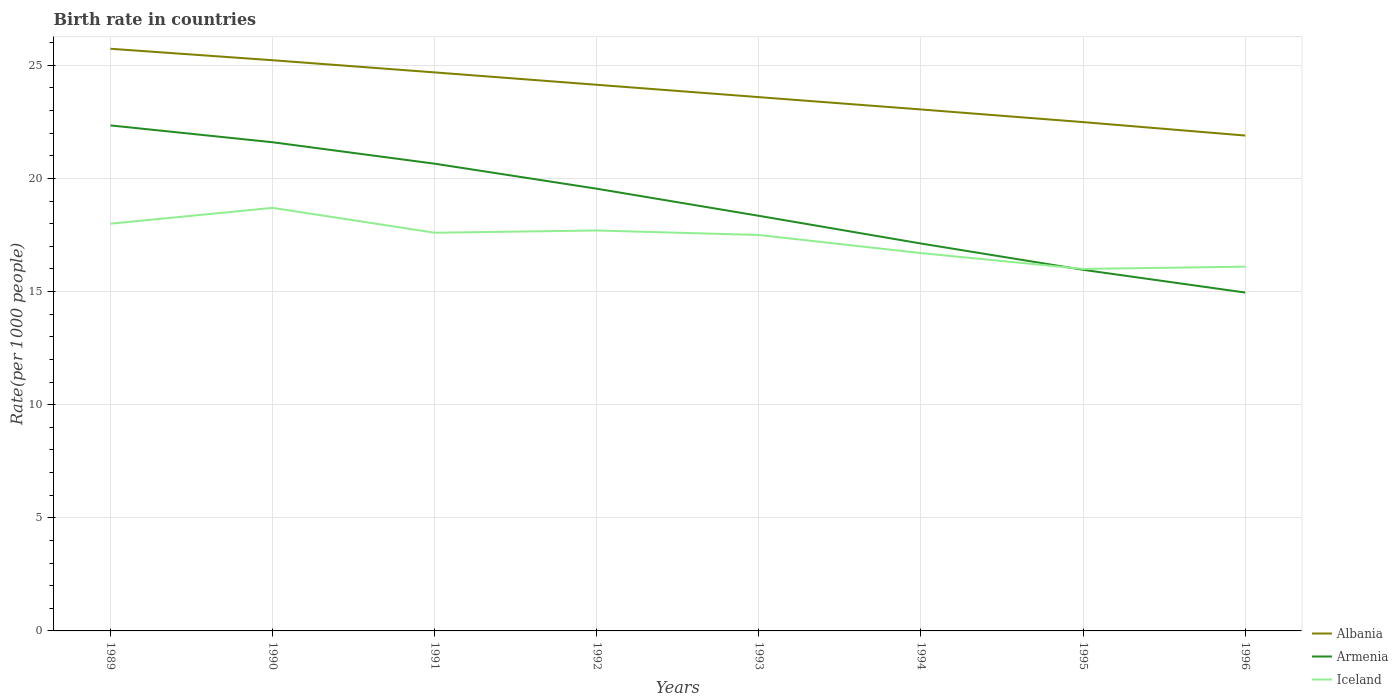How many different coloured lines are there?
Keep it short and to the point. 3. Does the line corresponding to Iceland intersect with the line corresponding to Albania?
Your answer should be very brief. No. Across all years, what is the maximum birth rate in Armenia?
Ensure brevity in your answer.  14.96. In which year was the birth rate in Albania maximum?
Your response must be concise. 1996. What is the total birth rate in Iceland in the graph?
Make the answer very short. 1.6. What is the difference between the highest and the second highest birth rate in Iceland?
Ensure brevity in your answer.  2.7. What is the difference between the highest and the lowest birth rate in Albania?
Provide a succinct answer. 4. How many lines are there?
Make the answer very short. 3. Are the values on the major ticks of Y-axis written in scientific E-notation?
Keep it short and to the point. No. Does the graph contain grids?
Your answer should be compact. Yes. Where does the legend appear in the graph?
Give a very brief answer. Bottom right. What is the title of the graph?
Offer a terse response. Birth rate in countries. Does "South Africa" appear as one of the legend labels in the graph?
Give a very brief answer. No. What is the label or title of the X-axis?
Ensure brevity in your answer.  Years. What is the label or title of the Y-axis?
Your answer should be compact. Rate(per 1000 people). What is the Rate(per 1000 people) of Albania in 1989?
Your answer should be compact. 25.73. What is the Rate(per 1000 people) of Armenia in 1989?
Keep it short and to the point. 22.34. What is the Rate(per 1000 people) in Albania in 1990?
Provide a short and direct response. 25.23. What is the Rate(per 1000 people) in Armenia in 1990?
Ensure brevity in your answer.  21.6. What is the Rate(per 1000 people) of Albania in 1991?
Offer a terse response. 24.69. What is the Rate(per 1000 people) in Armenia in 1991?
Offer a very short reply. 20.65. What is the Rate(per 1000 people) in Albania in 1992?
Your answer should be compact. 24.14. What is the Rate(per 1000 people) of Armenia in 1992?
Provide a short and direct response. 19.55. What is the Rate(per 1000 people) of Albania in 1993?
Provide a short and direct response. 23.59. What is the Rate(per 1000 people) in Armenia in 1993?
Offer a terse response. 18.35. What is the Rate(per 1000 people) in Albania in 1994?
Provide a succinct answer. 23.05. What is the Rate(per 1000 people) in Armenia in 1994?
Ensure brevity in your answer.  17.12. What is the Rate(per 1000 people) of Albania in 1995?
Offer a very short reply. 22.49. What is the Rate(per 1000 people) of Armenia in 1995?
Keep it short and to the point. 15.96. What is the Rate(per 1000 people) of Iceland in 1995?
Provide a short and direct response. 16. What is the Rate(per 1000 people) of Albania in 1996?
Your response must be concise. 21.9. What is the Rate(per 1000 people) of Armenia in 1996?
Offer a terse response. 14.96. Across all years, what is the maximum Rate(per 1000 people) of Albania?
Provide a succinct answer. 25.73. Across all years, what is the maximum Rate(per 1000 people) in Armenia?
Provide a short and direct response. 22.34. Across all years, what is the maximum Rate(per 1000 people) of Iceland?
Offer a terse response. 18.7. Across all years, what is the minimum Rate(per 1000 people) in Albania?
Your response must be concise. 21.9. Across all years, what is the minimum Rate(per 1000 people) of Armenia?
Make the answer very short. 14.96. Across all years, what is the minimum Rate(per 1000 people) of Iceland?
Your response must be concise. 16. What is the total Rate(per 1000 people) of Albania in the graph?
Keep it short and to the point. 190.81. What is the total Rate(per 1000 people) in Armenia in the graph?
Give a very brief answer. 150.53. What is the total Rate(per 1000 people) of Iceland in the graph?
Your response must be concise. 138.3. What is the difference between the Rate(per 1000 people) in Albania in 1989 and that in 1990?
Your response must be concise. 0.51. What is the difference between the Rate(per 1000 people) of Armenia in 1989 and that in 1990?
Make the answer very short. 0.74. What is the difference between the Rate(per 1000 people) of Albania in 1989 and that in 1991?
Give a very brief answer. 1.04. What is the difference between the Rate(per 1000 people) in Armenia in 1989 and that in 1991?
Your response must be concise. 1.69. What is the difference between the Rate(per 1000 people) of Iceland in 1989 and that in 1991?
Make the answer very short. 0.4. What is the difference between the Rate(per 1000 people) in Albania in 1989 and that in 1992?
Your answer should be very brief. 1.59. What is the difference between the Rate(per 1000 people) in Armenia in 1989 and that in 1992?
Provide a succinct answer. 2.8. What is the difference between the Rate(per 1000 people) in Iceland in 1989 and that in 1992?
Provide a short and direct response. 0.3. What is the difference between the Rate(per 1000 people) of Albania in 1989 and that in 1993?
Offer a very short reply. 2.14. What is the difference between the Rate(per 1000 people) in Armenia in 1989 and that in 1993?
Provide a short and direct response. 4. What is the difference between the Rate(per 1000 people) in Iceland in 1989 and that in 1993?
Provide a short and direct response. 0.5. What is the difference between the Rate(per 1000 people) in Albania in 1989 and that in 1994?
Give a very brief answer. 2.68. What is the difference between the Rate(per 1000 people) in Armenia in 1989 and that in 1994?
Your answer should be very brief. 5.22. What is the difference between the Rate(per 1000 people) in Albania in 1989 and that in 1995?
Provide a succinct answer. 3.24. What is the difference between the Rate(per 1000 people) in Armenia in 1989 and that in 1995?
Offer a very short reply. 6.38. What is the difference between the Rate(per 1000 people) of Iceland in 1989 and that in 1995?
Your response must be concise. 2. What is the difference between the Rate(per 1000 people) in Albania in 1989 and that in 1996?
Provide a succinct answer. 3.84. What is the difference between the Rate(per 1000 people) in Armenia in 1989 and that in 1996?
Offer a terse response. 7.39. What is the difference between the Rate(per 1000 people) in Albania in 1990 and that in 1991?
Your response must be concise. 0.54. What is the difference between the Rate(per 1000 people) in Armenia in 1990 and that in 1991?
Ensure brevity in your answer.  0.95. What is the difference between the Rate(per 1000 people) of Iceland in 1990 and that in 1991?
Provide a short and direct response. 1.1. What is the difference between the Rate(per 1000 people) of Albania in 1990 and that in 1992?
Give a very brief answer. 1.08. What is the difference between the Rate(per 1000 people) in Armenia in 1990 and that in 1992?
Your answer should be compact. 2.05. What is the difference between the Rate(per 1000 people) in Albania in 1990 and that in 1993?
Provide a succinct answer. 1.63. What is the difference between the Rate(per 1000 people) in Armenia in 1990 and that in 1993?
Your answer should be compact. 3.25. What is the difference between the Rate(per 1000 people) in Albania in 1990 and that in 1994?
Your answer should be very brief. 2.18. What is the difference between the Rate(per 1000 people) of Armenia in 1990 and that in 1994?
Provide a short and direct response. 4.48. What is the difference between the Rate(per 1000 people) in Albania in 1990 and that in 1995?
Your response must be concise. 2.73. What is the difference between the Rate(per 1000 people) in Armenia in 1990 and that in 1995?
Ensure brevity in your answer.  5.64. What is the difference between the Rate(per 1000 people) of Iceland in 1990 and that in 1995?
Ensure brevity in your answer.  2.7. What is the difference between the Rate(per 1000 people) of Albania in 1990 and that in 1996?
Make the answer very short. 3.33. What is the difference between the Rate(per 1000 people) of Armenia in 1990 and that in 1996?
Provide a short and direct response. 6.64. What is the difference between the Rate(per 1000 people) of Albania in 1991 and that in 1992?
Make the answer very short. 0.55. What is the difference between the Rate(per 1000 people) of Armenia in 1991 and that in 1992?
Your response must be concise. 1.11. What is the difference between the Rate(per 1000 people) in Albania in 1991 and that in 1993?
Your answer should be compact. 1.09. What is the difference between the Rate(per 1000 people) of Armenia in 1991 and that in 1993?
Give a very brief answer. 2.3. What is the difference between the Rate(per 1000 people) of Iceland in 1991 and that in 1993?
Offer a terse response. 0.1. What is the difference between the Rate(per 1000 people) of Albania in 1991 and that in 1994?
Ensure brevity in your answer.  1.64. What is the difference between the Rate(per 1000 people) in Armenia in 1991 and that in 1994?
Ensure brevity in your answer.  3.53. What is the difference between the Rate(per 1000 people) of Albania in 1991 and that in 1995?
Make the answer very short. 2.2. What is the difference between the Rate(per 1000 people) of Armenia in 1991 and that in 1995?
Keep it short and to the point. 4.69. What is the difference between the Rate(per 1000 people) in Albania in 1991 and that in 1996?
Your response must be concise. 2.79. What is the difference between the Rate(per 1000 people) of Armenia in 1991 and that in 1996?
Make the answer very short. 5.7. What is the difference between the Rate(per 1000 people) in Albania in 1992 and that in 1993?
Give a very brief answer. 0.55. What is the difference between the Rate(per 1000 people) in Armenia in 1992 and that in 1993?
Ensure brevity in your answer.  1.2. What is the difference between the Rate(per 1000 people) of Iceland in 1992 and that in 1993?
Keep it short and to the point. 0.2. What is the difference between the Rate(per 1000 people) of Albania in 1992 and that in 1994?
Offer a very short reply. 1.09. What is the difference between the Rate(per 1000 people) in Armenia in 1992 and that in 1994?
Make the answer very short. 2.42. What is the difference between the Rate(per 1000 people) of Iceland in 1992 and that in 1994?
Your answer should be very brief. 1. What is the difference between the Rate(per 1000 people) in Albania in 1992 and that in 1995?
Ensure brevity in your answer.  1.65. What is the difference between the Rate(per 1000 people) of Armenia in 1992 and that in 1995?
Keep it short and to the point. 3.58. What is the difference between the Rate(per 1000 people) in Albania in 1992 and that in 1996?
Your response must be concise. 2.24. What is the difference between the Rate(per 1000 people) of Armenia in 1992 and that in 1996?
Your answer should be very brief. 4.59. What is the difference between the Rate(per 1000 people) in Iceland in 1992 and that in 1996?
Your response must be concise. 1.6. What is the difference between the Rate(per 1000 people) of Albania in 1993 and that in 1994?
Offer a very short reply. 0.55. What is the difference between the Rate(per 1000 people) in Armenia in 1993 and that in 1994?
Provide a short and direct response. 1.23. What is the difference between the Rate(per 1000 people) of Albania in 1993 and that in 1995?
Make the answer very short. 1.1. What is the difference between the Rate(per 1000 people) of Armenia in 1993 and that in 1995?
Provide a succinct answer. 2.39. What is the difference between the Rate(per 1000 people) of Albania in 1993 and that in 1996?
Provide a succinct answer. 1.7. What is the difference between the Rate(per 1000 people) of Armenia in 1993 and that in 1996?
Ensure brevity in your answer.  3.39. What is the difference between the Rate(per 1000 people) of Albania in 1994 and that in 1995?
Give a very brief answer. 0.56. What is the difference between the Rate(per 1000 people) of Armenia in 1994 and that in 1995?
Ensure brevity in your answer.  1.16. What is the difference between the Rate(per 1000 people) in Albania in 1994 and that in 1996?
Provide a succinct answer. 1.15. What is the difference between the Rate(per 1000 people) in Armenia in 1994 and that in 1996?
Offer a very short reply. 2.17. What is the difference between the Rate(per 1000 people) of Iceland in 1994 and that in 1996?
Make the answer very short. 0.6. What is the difference between the Rate(per 1000 people) of Albania in 1995 and that in 1996?
Keep it short and to the point. 0.59. What is the difference between the Rate(per 1000 people) of Armenia in 1995 and that in 1996?
Make the answer very short. 1. What is the difference between the Rate(per 1000 people) of Albania in 1989 and the Rate(per 1000 people) of Armenia in 1990?
Ensure brevity in your answer.  4.13. What is the difference between the Rate(per 1000 people) in Albania in 1989 and the Rate(per 1000 people) in Iceland in 1990?
Offer a very short reply. 7.03. What is the difference between the Rate(per 1000 people) of Armenia in 1989 and the Rate(per 1000 people) of Iceland in 1990?
Offer a very short reply. 3.64. What is the difference between the Rate(per 1000 people) in Albania in 1989 and the Rate(per 1000 people) in Armenia in 1991?
Provide a short and direct response. 5.08. What is the difference between the Rate(per 1000 people) of Albania in 1989 and the Rate(per 1000 people) of Iceland in 1991?
Your answer should be very brief. 8.13. What is the difference between the Rate(per 1000 people) of Armenia in 1989 and the Rate(per 1000 people) of Iceland in 1991?
Give a very brief answer. 4.74. What is the difference between the Rate(per 1000 people) of Albania in 1989 and the Rate(per 1000 people) of Armenia in 1992?
Your answer should be very brief. 6.19. What is the difference between the Rate(per 1000 people) of Albania in 1989 and the Rate(per 1000 people) of Iceland in 1992?
Provide a succinct answer. 8.03. What is the difference between the Rate(per 1000 people) in Armenia in 1989 and the Rate(per 1000 people) in Iceland in 1992?
Offer a very short reply. 4.64. What is the difference between the Rate(per 1000 people) of Albania in 1989 and the Rate(per 1000 people) of Armenia in 1993?
Make the answer very short. 7.38. What is the difference between the Rate(per 1000 people) of Albania in 1989 and the Rate(per 1000 people) of Iceland in 1993?
Provide a short and direct response. 8.23. What is the difference between the Rate(per 1000 people) in Armenia in 1989 and the Rate(per 1000 people) in Iceland in 1993?
Your answer should be very brief. 4.84. What is the difference between the Rate(per 1000 people) in Albania in 1989 and the Rate(per 1000 people) in Armenia in 1994?
Ensure brevity in your answer.  8.61. What is the difference between the Rate(per 1000 people) of Albania in 1989 and the Rate(per 1000 people) of Iceland in 1994?
Your answer should be very brief. 9.03. What is the difference between the Rate(per 1000 people) of Armenia in 1989 and the Rate(per 1000 people) of Iceland in 1994?
Provide a succinct answer. 5.64. What is the difference between the Rate(per 1000 people) in Albania in 1989 and the Rate(per 1000 people) in Armenia in 1995?
Offer a very short reply. 9.77. What is the difference between the Rate(per 1000 people) in Albania in 1989 and the Rate(per 1000 people) in Iceland in 1995?
Your answer should be compact. 9.73. What is the difference between the Rate(per 1000 people) of Armenia in 1989 and the Rate(per 1000 people) of Iceland in 1995?
Ensure brevity in your answer.  6.34. What is the difference between the Rate(per 1000 people) in Albania in 1989 and the Rate(per 1000 people) in Armenia in 1996?
Offer a very short reply. 10.78. What is the difference between the Rate(per 1000 people) in Albania in 1989 and the Rate(per 1000 people) in Iceland in 1996?
Provide a succinct answer. 9.63. What is the difference between the Rate(per 1000 people) of Armenia in 1989 and the Rate(per 1000 people) of Iceland in 1996?
Your answer should be compact. 6.24. What is the difference between the Rate(per 1000 people) in Albania in 1990 and the Rate(per 1000 people) in Armenia in 1991?
Give a very brief answer. 4.57. What is the difference between the Rate(per 1000 people) of Albania in 1990 and the Rate(per 1000 people) of Iceland in 1991?
Provide a succinct answer. 7.62. What is the difference between the Rate(per 1000 people) of Armenia in 1990 and the Rate(per 1000 people) of Iceland in 1991?
Your answer should be very brief. 4. What is the difference between the Rate(per 1000 people) of Albania in 1990 and the Rate(per 1000 people) of Armenia in 1992?
Your response must be concise. 5.68. What is the difference between the Rate(per 1000 people) in Albania in 1990 and the Rate(per 1000 people) in Iceland in 1992?
Make the answer very short. 7.53. What is the difference between the Rate(per 1000 people) in Albania in 1990 and the Rate(per 1000 people) in Armenia in 1993?
Your response must be concise. 6.88. What is the difference between the Rate(per 1000 people) of Albania in 1990 and the Rate(per 1000 people) of Iceland in 1993?
Your response must be concise. 7.72. What is the difference between the Rate(per 1000 people) in Armenia in 1990 and the Rate(per 1000 people) in Iceland in 1993?
Keep it short and to the point. 4.1. What is the difference between the Rate(per 1000 people) of Albania in 1990 and the Rate(per 1000 people) of Armenia in 1994?
Offer a terse response. 8.1. What is the difference between the Rate(per 1000 people) of Albania in 1990 and the Rate(per 1000 people) of Iceland in 1994?
Keep it short and to the point. 8.53. What is the difference between the Rate(per 1000 people) of Armenia in 1990 and the Rate(per 1000 people) of Iceland in 1994?
Provide a succinct answer. 4.9. What is the difference between the Rate(per 1000 people) in Albania in 1990 and the Rate(per 1000 people) in Armenia in 1995?
Ensure brevity in your answer.  9.26. What is the difference between the Rate(per 1000 people) of Albania in 1990 and the Rate(per 1000 people) of Iceland in 1995?
Your answer should be very brief. 9.22. What is the difference between the Rate(per 1000 people) of Armenia in 1990 and the Rate(per 1000 people) of Iceland in 1995?
Offer a terse response. 5.6. What is the difference between the Rate(per 1000 people) of Albania in 1990 and the Rate(per 1000 people) of Armenia in 1996?
Provide a short and direct response. 10.27. What is the difference between the Rate(per 1000 people) of Albania in 1990 and the Rate(per 1000 people) of Iceland in 1996?
Offer a very short reply. 9.12. What is the difference between the Rate(per 1000 people) in Armenia in 1990 and the Rate(per 1000 people) in Iceland in 1996?
Make the answer very short. 5.5. What is the difference between the Rate(per 1000 people) in Albania in 1991 and the Rate(per 1000 people) in Armenia in 1992?
Provide a short and direct response. 5.14. What is the difference between the Rate(per 1000 people) in Albania in 1991 and the Rate(per 1000 people) in Iceland in 1992?
Give a very brief answer. 6.99. What is the difference between the Rate(per 1000 people) in Armenia in 1991 and the Rate(per 1000 people) in Iceland in 1992?
Offer a very short reply. 2.95. What is the difference between the Rate(per 1000 people) of Albania in 1991 and the Rate(per 1000 people) of Armenia in 1993?
Provide a short and direct response. 6.34. What is the difference between the Rate(per 1000 people) in Albania in 1991 and the Rate(per 1000 people) in Iceland in 1993?
Ensure brevity in your answer.  7.19. What is the difference between the Rate(per 1000 people) in Armenia in 1991 and the Rate(per 1000 people) in Iceland in 1993?
Your answer should be very brief. 3.15. What is the difference between the Rate(per 1000 people) of Albania in 1991 and the Rate(per 1000 people) of Armenia in 1994?
Provide a succinct answer. 7.56. What is the difference between the Rate(per 1000 people) in Albania in 1991 and the Rate(per 1000 people) in Iceland in 1994?
Provide a succinct answer. 7.99. What is the difference between the Rate(per 1000 people) of Armenia in 1991 and the Rate(per 1000 people) of Iceland in 1994?
Your answer should be compact. 3.95. What is the difference between the Rate(per 1000 people) of Albania in 1991 and the Rate(per 1000 people) of Armenia in 1995?
Make the answer very short. 8.72. What is the difference between the Rate(per 1000 people) in Albania in 1991 and the Rate(per 1000 people) in Iceland in 1995?
Offer a terse response. 8.69. What is the difference between the Rate(per 1000 people) of Armenia in 1991 and the Rate(per 1000 people) of Iceland in 1995?
Ensure brevity in your answer.  4.65. What is the difference between the Rate(per 1000 people) in Albania in 1991 and the Rate(per 1000 people) in Armenia in 1996?
Make the answer very short. 9.73. What is the difference between the Rate(per 1000 people) in Albania in 1991 and the Rate(per 1000 people) in Iceland in 1996?
Keep it short and to the point. 8.59. What is the difference between the Rate(per 1000 people) in Armenia in 1991 and the Rate(per 1000 people) in Iceland in 1996?
Your response must be concise. 4.55. What is the difference between the Rate(per 1000 people) of Albania in 1992 and the Rate(per 1000 people) of Armenia in 1993?
Keep it short and to the point. 5.79. What is the difference between the Rate(per 1000 people) of Albania in 1992 and the Rate(per 1000 people) of Iceland in 1993?
Offer a very short reply. 6.64. What is the difference between the Rate(per 1000 people) of Armenia in 1992 and the Rate(per 1000 people) of Iceland in 1993?
Your answer should be very brief. 2.05. What is the difference between the Rate(per 1000 people) in Albania in 1992 and the Rate(per 1000 people) in Armenia in 1994?
Offer a terse response. 7.02. What is the difference between the Rate(per 1000 people) in Albania in 1992 and the Rate(per 1000 people) in Iceland in 1994?
Your answer should be compact. 7.44. What is the difference between the Rate(per 1000 people) of Armenia in 1992 and the Rate(per 1000 people) of Iceland in 1994?
Offer a very short reply. 2.85. What is the difference between the Rate(per 1000 people) of Albania in 1992 and the Rate(per 1000 people) of Armenia in 1995?
Make the answer very short. 8.18. What is the difference between the Rate(per 1000 people) in Albania in 1992 and the Rate(per 1000 people) in Iceland in 1995?
Keep it short and to the point. 8.14. What is the difference between the Rate(per 1000 people) of Armenia in 1992 and the Rate(per 1000 people) of Iceland in 1995?
Your answer should be compact. 3.55. What is the difference between the Rate(per 1000 people) of Albania in 1992 and the Rate(per 1000 people) of Armenia in 1996?
Make the answer very short. 9.18. What is the difference between the Rate(per 1000 people) of Albania in 1992 and the Rate(per 1000 people) of Iceland in 1996?
Make the answer very short. 8.04. What is the difference between the Rate(per 1000 people) of Armenia in 1992 and the Rate(per 1000 people) of Iceland in 1996?
Make the answer very short. 3.45. What is the difference between the Rate(per 1000 people) of Albania in 1993 and the Rate(per 1000 people) of Armenia in 1994?
Offer a very short reply. 6.47. What is the difference between the Rate(per 1000 people) of Albania in 1993 and the Rate(per 1000 people) of Iceland in 1994?
Provide a short and direct response. 6.89. What is the difference between the Rate(per 1000 people) of Armenia in 1993 and the Rate(per 1000 people) of Iceland in 1994?
Make the answer very short. 1.65. What is the difference between the Rate(per 1000 people) of Albania in 1993 and the Rate(per 1000 people) of Armenia in 1995?
Offer a terse response. 7.63. What is the difference between the Rate(per 1000 people) of Albania in 1993 and the Rate(per 1000 people) of Iceland in 1995?
Your answer should be very brief. 7.59. What is the difference between the Rate(per 1000 people) of Armenia in 1993 and the Rate(per 1000 people) of Iceland in 1995?
Your response must be concise. 2.35. What is the difference between the Rate(per 1000 people) in Albania in 1993 and the Rate(per 1000 people) in Armenia in 1996?
Provide a succinct answer. 8.64. What is the difference between the Rate(per 1000 people) in Albania in 1993 and the Rate(per 1000 people) in Iceland in 1996?
Provide a succinct answer. 7.49. What is the difference between the Rate(per 1000 people) of Armenia in 1993 and the Rate(per 1000 people) of Iceland in 1996?
Make the answer very short. 2.25. What is the difference between the Rate(per 1000 people) in Albania in 1994 and the Rate(per 1000 people) in Armenia in 1995?
Your response must be concise. 7.09. What is the difference between the Rate(per 1000 people) of Albania in 1994 and the Rate(per 1000 people) of Iceland in 1995?
Make the answer very short. 7.05. What is the difference between the Rate(per 1000 people) of Armenia in 1994 and the Rate(per 1000 people) of Iceland in 1995?
Offer a terse response. 1.12. What is the difference between the Rate(per 1000 people) of Albania in 1994 and the Rate(per 1000 people) of Armenia in 1996?
Provide a succinct answer. 8.09. What is the difference between the Rate(per 1000 people) in Albania in 1994 and the Rate(per 1000 people) in Iceland in 1996?
Your answer should be very brief. 6.95. What is the difference between the Rate(per 1000 people) in Albania in 1995 and the Rate(per 1000 people) in Armenia in 1996?
Give a very brief answer. 7.53. What is the difference between the Rate(per 1000 people) in Albania in 1995 and the Rate(per 1000 people) in Iceland in 1996?
Make the answer very short. 6.39. What is the difference between the Rate(per 1000 people) of Armenia in 1995 and the Rate(per 1000 people) of Iceland in 1996?
Give a very brief answer. -0.14. What is the average Rate(per 1000 people) in Albania per year?
Make the answer very short. 23.85. What is the average Rate(per 1000 people) in Armenia per year?
Keep it short and to the point. 18.82. What is the average Rate(per 1000 people) of Iceland per year?
Provide a succinct answer. 17.29. In the year 1989, what is the difference between the Rate(per 1000 people) in Albania and Rate(per 1000 people) in Armenia?
Your answer should be very brief. 3.39. In the year 1989, what is the difference between the Rate(per 1000 people) in Albania and Rate(per 1000 people) in Iceland?
Ensure brevity in your answer.  7.73. In the year 1989, what is the difference between the Rate(per 1000 people) of Armenia and Rate(per 1000 people) of Iceland?
Offer a terse response. 4.34. In the year 1990, what is the difference between the Rate(per 1000 people) in Albania and Rate(per 1000 people) in Armenia?
Provide a short and direct response. 3.62. In the year 1990, what is the difference between the Rate(per 1000 people) in Albania and Rate(per 1000 people) in Iceland?
Your answer should be very brief. 6.53. In the year 1990, what is the difference between the Rate(per 1000 people) of Armenia and Rate(per 1000 people) of Iceland?
Provide a short and direct response. 2.9. In the year 1991, what is the difference between the Rate(per 1000 people) of Albania and Rate(per 1000 people) of Armenia?
Give a very brief answer. 4.04. In the year 1991, what is the difference between the Rate(per 1000 people) of Albania and Rate(per 1000 people) of Iceland?
Offer a terse response. 7.09. In the year 1991, what is the difference between the Rate(per 1000 people) in Armenia and Rate(per 1000 people) in Iceland?
Make the answer very short. 3.05. In the year 1992, what is the difference between the Rate(per 1000 people) of Albania and Rate(per 1000 people) of Armenia?
Make the answer very short. 4.59. In the year 1992, what is the difference between the Rate(per 1000 people) in Albania and Rate(per 1000 people) in Iceland?
Provide a short and direct response. 6.44. In the year 1992, what is the difference between the Rate(per 1000 people) in Armenia and Rate(per 1000 people) in Iceland?
Provide a short and direct response. 1.85. In the year 1993, what is the difference between the Rate(per 1000 people) in Albania and Rate(per 1000 people) in Armenia?
Give a very brief answer. 5.25. In the year 1993, what is the difference between the Rate(per 1000 people) in Albania and Rate(per 1000 people) in Iceland?
Give a very brief answer. 6.09. In the year 1993, what is the difference between the Rate(per 1000 people) of Armenia and Rate(per 1000 people) of Iceland?
Your response must be concise. 0.85. In the year 1994, what is the difference between the Rate(per 1000 people) of Albania and Rate(per 1000 people) of Armenia?
Provide a succinct answer. 5.93. In the year 1994, what is the difference between the Rate(per 1000 people) of Albania and Rate(per 1000 people) of Iceland?
Make the answer very short. 6.35. In the year 1994, what is the difference between the Rate(per 1000 people) in Armenia and Rate(per 1000 people) in Iceland?
Your response must be concise. 0.42. In the year 1995, what is the difference between the Rate(per 1000 people) of Albania and Rate(per 1000 people) of Armenia?
Give a very brief answer. 6.53. In the year 1995, what is the difference between the Rate(per 1000 people) in Albania and Rate(per 1000 people) in Iceland?
Your answer should be very brief. 6.49. In the year 1995, what is the difference between the Rate(per 1000 people) in Armenia and Rate(per 1000 people) in Iceland?
Keep it short and to the point. -0.04. In the year 1996, what is the difference between the Rate(per 1000 people) of Albania and Rate(per 1000 people) of Armenia?
Give a very brief answer. 6.94. In the year 1996, what is the difference between the Rate(per 1000 people) of Albania and Rate(per 1000 people) of Iceland?
Make the answer very short. 5.8. In the year 1996, what is the difference between the Rate(per 1000 people) in Armenia and Rate(per 1000 people) in Iceland?
Provide a succinct answer. -1.14. What is the ratio of the Rate(per 1000 people) of Albania in 1989 to that in 1990?
Provide a succinct answer. 1.02. What is the ratio of the Rate(per 1000 people) of Armenia in 1989 to that in 1990?
Ensure brevity in your answer.  1.03. What is the ratio of the Rate(per 1000 people) of Iceland in 1989 to that in 1990?
Your answer should be compact. 0.96. What is the ratio of the Rate(per 1000 people) in Albania in 1989 to that in 1991?
Provide a succinct answer. 1.04. What is the ratio of the Rate(per 1000 people) in Armenia in 1989 to that in 1991?
Provide a short and direct response. 1.08. What is the ratio of the Rate(per 1000 people) of Iceland in 1989 to that in 1991?
Your answer should be compact. 1.02. What is the ratio of the Rate(per 1000 people) of Albania in 1989 to that in 1992?
Ensure brevity in your answer.  1.07. What is the ratio of the Rate(per 1000 people) of Armenia in 1989 to that in 1992?
Offer a very short reply. 1.14. What is the ratio of the Rate(per 1000 people) in Iceland in 1989 to that in 1992?
Give a very brief answer. 1.02. What is the ratio of the Rate(per 1000 people) of Albania in 1989 to that in 1993?
Your answer should be very brief. 1.09. What is the ratio of the Rate(per 1000 people) in Armenia in 1989 to that in 1993?
Give a very brief answer. 1.22. What is the ratio of the Rate(per 1000 people) of Iceland in 1989 to that in 1993?
Ensure brevity in your answer.  1.03. What is the ratio of the Rate(per 1000 people) in Albania in 1989 to that in 1994?
Offer a terse response. 1.12. What is the ratio of the Rate(per 1000 people) of Armenia in 1989 to that in 1994?
Keep it short and to the point. 1.3. What is the ratio of the Rate(per 1000 people) of Iceland in 1989 to that in 1994?
Make the answer very short. 1.08. What is the ratio of the Rate(per 1000 people) in Albania in 1989 to that in 1995?
Give a very brief answer. 1.14. What is the ratio of the Rate(per 1000 people) of Armenia in 1989 to that in 1995?
Give a very brief answer. 1.4. What is the ratio of the Rate(per 1000 people) of Albania in 1989 to that in 1996?
Make the answer very short. 1.18. What is the ratio of the Rate(per 1000 people) in Armenia in 1989 to that in 1996?
Make the answer very short. 1.49. What is the ratio of the Rate(per 1000 people) of Iceland in 1989 to that in 1996?
Offer a terse response. 1.12. What is the ratio of the Rate(per 1000 people) of Albania in 1990 to that in 1991?
Your answer should be compact. 1.02. What is the ratio of the Rate(per 1000 people) in Armenia in 1990 to that in 1991?
Provide a short and direct response. 1.05. What is the ratio of the Rate(per 1000 people) in Albania in 1990 to that in 1992?
Offer a very short reply. 1.04. What is the ratio of the Rate(per 1000 people) in Armenia in 1990 to that in 1992?
Make the answer very short. 1.11. What is the ratio of the Rate(per 1000 people) of Iceland in 1990 to that in 1992?
Your answer should be compact. 1.06. What is the ratio of the Rate(per 1000 people) of Albania in 1990 to that in 1993?
Offer a very short reply. 1.07. What is the ratio of the Rate(per 1000 people) in Armenia in 1990 to that in 1993?
Ensure brevity in your answer.  1.18. What is the ratio of the Rate(per 1000 people) of Iceland in 1990 to that in 1993?
Your answer should be very brief. 1.07. What is the ratio of the Rate(per 1000 people) of Albania in 1990 to that in 1994?
Your response must be concise. 1.09. What is the ratio of the Rate(per 1000 people) in Armenia in 1990 to that in 1994?
Your answer should be very brief. 1.26. What is the ratio of the Rate(per 1000 people) of Iceland in 1990 to that in 1994?
Provide a short and direct response. 1.12. What is the ratio of the Rate(per 1000 people) of Albania in 1990 to that in 1995?
Your answer should be compact. 1.12. What is the ratio of the Rate(per 1000 people) of Armenia in 1990 to that in 1995?
Ensure brevity in your answer.  1.35. What is the ratio of the Rate(per 1000 people) of Iceland in 1990 to that in 1995?
Offer a very short reply. 1.17. What is the ratio of the Rate(per 1000 people) in Albania in 1990 to that in 1996?
Ensure brevity in your answer.  1.15. What is the ratio of the Rate(per 1000 people) of Armenia in 1990 to that in 1996?
Provide a succinct answer. 1.44. What is the ratio of the Rate(per 1000 people) of Iceland in 1990 to that in 1996?
Provide a succinct answer. 1.16. What is the ratio of the Rate(per 1000 people) of Albania in 1991 to that in 1992?
Your answer should be compact. 1.02. What is the ratio of the Rate(per 1000 people) of Armenia in 1991 to that in 1992?
Keep it short and to the point. 1.06. What is the ratio of the Rate(per 1000 people) in Iceland in 1991 to that in 1992?
Offer a terse response. 0.99. What is the ratio of the Rate(per 1000 people) in Albania in 1991 to that in 1993?
Your response must be concise. 1.05. What is the ratio of the Rate(per 1000 people) of Armenia in 1991 to that in 1993?
Your answer should be compact. 1.13. What is the ratio of the Rate(per 1000 people) in Albania in 1991 to that in 1994?
Your answer should be compact. 1.07. What is the ratio of the Rate(per 1000 people) of Armenia in 1991 to that in 1994?
Offer a terse response. 1.21. What is the ratio of the Rate(per 1000 people) in Iceland in 1991 to that in 1994?
Keep it short and to the point. 1.05. What is the ratio of the Rate(per 1000 people) of Albania in 1991 to that in 1995?
Ensure brevity in your answer.  1.1. What is the ratio of the Rate(per 1000 people) of Armenia in 1991 to that in 1995?
Your answer should be compact. 1.29. What is the ratio of the Rate(per 1000 people) of Albania in 1991 to that in 1996?
Offer a very short reply. 1.13. What is the ratio of the Rate(per 1000 people) of Armenia in 1991 to that in 1996?
Give a very brief answer. 1.38. What is the ratio of the Rate(per 1000 people) of Iceland in 1991 to that in 1996?
Provide a short and direct response. 1.09. What is the ratio of the Rate(per 1000 people) in Albania in 1992 to that in 1993?
Your response must be concise. 1.02. What is the ratio of the Rate(per 1000 people) in Armenia in 1992 to that in 1993?
Provide a short and direct response. 1.07. What is the ratio of the Rate(per 1000 people) of Iceland in 1992 to that in 1993?
Ensure brevity in your answer.  1.01. What is the ratio of the Rate(per 1000 people) in Albania in 1992 to that in 1994?
Provide a succinct answer. 1.05. What is the ratio of the Rate(per 1000 people) in Armenia in 1992 to that in 1994?
Offer a terse response. 1.14. What is the ratio of the Rate(per 1000 people) of Iceland in 1992 to that in 1994?
Keep it short and to the point. 1.06. What is the ratio of the Rate(per 1000 people) of Albania in 1992 to that in 1995?
Your response must be concise. 1.07. What is the ratio of the Rate(per 1000 people) in Armenia in 1992 to that in 1995?
Keep it short and to the point. 1.22. What is the ratio of the Rate(per 1000 people) in Iceland in 1992 to that in 1995?
Make the answer very short. 1.11. What is the ratio of the Rate(per 1000 people) of Albania in 1992 to that in 1996?
Your answer should be compact. 1.1. What is the ratio of the Rate(per 1000 people) of Armenia in 1992 to that in 1996?
Give a very brief answer. 1.31. What is the ratio of the Rate(per 1000 people) of Iceland in 1992 to that in 1996?
Offer a very short reply. 1.1. What is the ratio of the Rate(per 1000 people) in Albania in 1993 to that in 1994?
Offer a terse response. 1.02. What is the ratio of the Rate(per 1000 people) of Armenia in 1993 to that in 1994?
Provide a short and direct response. 1.07. What is the ratio of the Rate(per 1000 people) of Iceland in 1993 to that in 1994?
Your answer should be compact. 1.05. What is the ratio of the Rate(per 1000 people) in Albania in 1993 to that in 1995?
Ensure brevity in your answer.  1.05. What is the ratio of the Rate(per 1000 people) in Armenia in 1993 to that in 1995?
Provide a short and direct response. 1.15. What is the ratio of the Rate(per 1000 people) in Iceland in 1993 to that in 1995?
Give a very brief answer. 1.09. What is the ratio of the Rate(per 1000 people) in Albania in 1993 to that in 1996?
Ensure brevity in your answer.  1.08. What is the ratio of the Rate(per 1000 people) in Armenia in 1993 to that in 1996?
Your answer should be very brief. 1.23. What is the ratio of the Rate(per 1000 people) of Iceland in 1993 to that in 1996?
Make the answer very short. 1.09. What is the ratio of the Rate(per 1000 people) in Albania in 1994 to that in 1995?
Give a very brief answer. 1.02. What is the ratio of the Rate(per 1000 people) in Armenia in 1994 to that in 1995?
Keep it short and to the point. 1.07. What is the ratio of the Rate(per 1000 people) in Iceland in 1994 to that in 1995?
Make the answer very short. 1.04. What is the ratio of the Rate(per 1000 people) in Albania in 1994 to that in 1996?
Your answer should be compact. 1.05. What is the ratio of the Rate(per 1000 people) of Armenia in 1994 to that in 1996?
Provide a short and direct response. 1.14. What is the ratio of the Rate(per 1000 people) of Iceland in 1994 to that in 1996?
Make the answer very short. 1.04. What is the ratio of the Rate(per 1000 people) in Albania in 1995 to that in 1996?
Ensure brevity in your answer.  1.03. What is the ratio of the Rate(per 1000 people) of Armenia in 1995 to that in 1996?
Your answer should be very brief. 1.07. What is the difference between the highest and the second highest Rate(per 1000 people) in Albania?
Provide a succinct answer. 0.51. What is the difference between the highest and the second highest Rate(per 1000 people) in Armenia?
Offer a very short reply. 0.74. What is the difference between the highest and the lowest Rate(per 1000 people) of Albania?
Offer a very short reply. 3.84. What is the difference between the highest and the lowest Rate(per 1000 people) of Armenia?
Make the answer very short. 7.39. What is the difference between the highest and the lowest Rate(per 1000 people) in Iceland?
Make the answer very short. 2.7. 